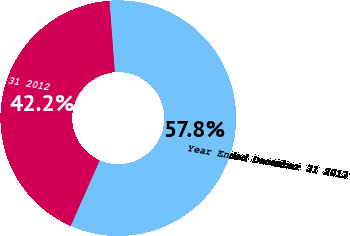Convert chart. <chart><loc_0><loc_0><loc_500><loc_500><pie_chart><fcel>Year Ended December 31 2013<fcel>Year Ended December 31 2012<nl><fcel>57.81%<fcel>42.19%<nl></chart> 